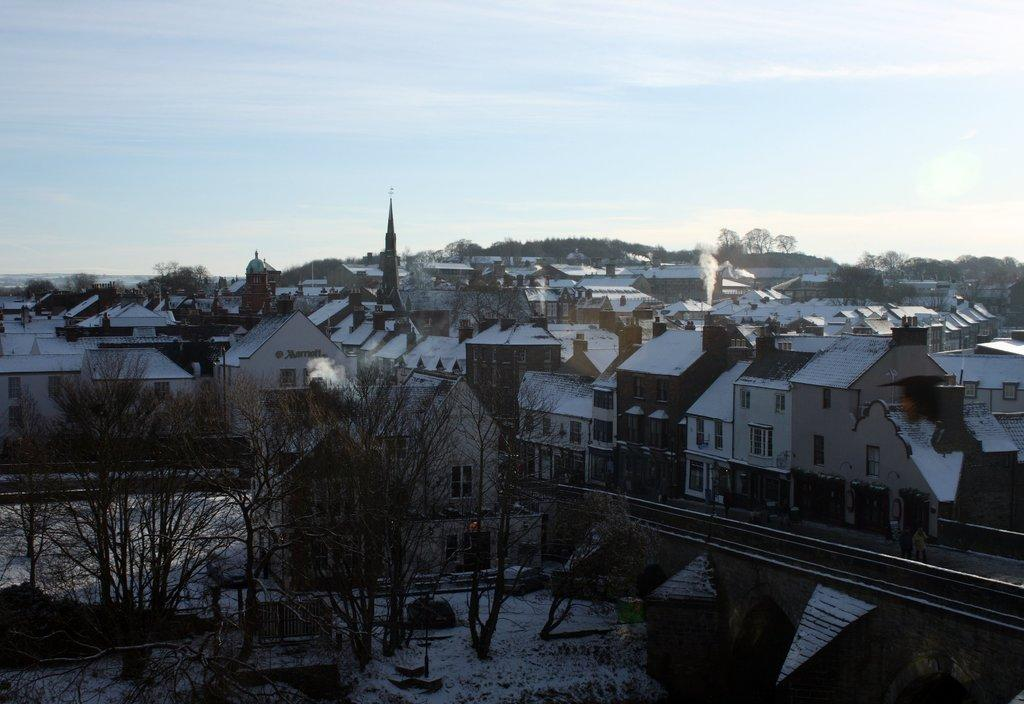What type of natural elements can be seen in the image? There are trees in the image. What type of man-made structures are visible in the background? There are buildings in the background of the image. What colors are the buildings in the image? The buildings are in white, brown, and cream colors. What is visible in the top part of the image? The sky is visible in the image. What colors can be seen in the sky? The sky is a combination of white and blue colors. What language is being spoken by the trees in the image? Trees do not speak any language, so this question cannot be answered. Can you see any cords connecting the buildings in the image? There is no mention of cords in the image, so we cannot determine if any are present. 